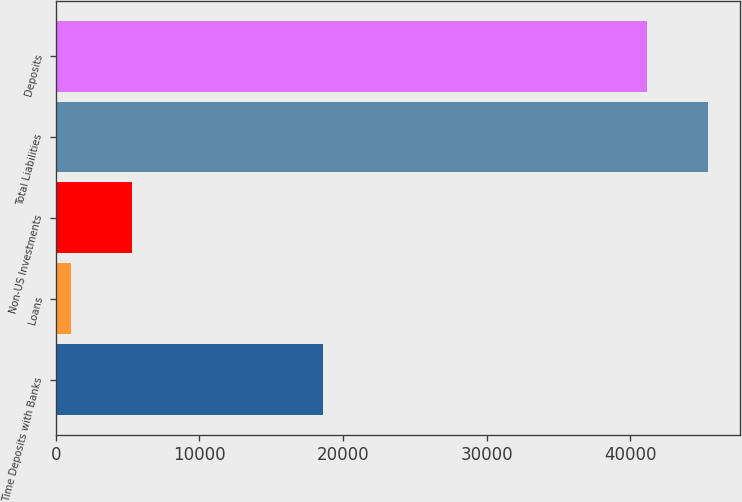Convert chart to OTSL. <chart><loc_0><loc_0><loc_500><loc_500><bar_chart><fcel>Time Deposits with Banks<fcel>Loans<fcel>Non-US Investments<fcel>Total Liabilities<fcel>Deposits<nl><fcel>18580.4<fcel>1091.1<fcel>5325.66<fcel>45395.5<fcel>41160.9<nl></chart> 